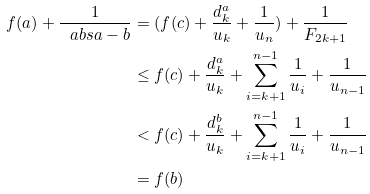<formula> <loc_0><loc_0><loc_500><loc_500>f ( a ) + \frac { 1 } { \ a b s { a - b } } & = ( f ( c ) + \frac { d ^ { a } _ { k } } { u _ { k } } + \frac { 1 } { u _ { n } } ) + \frac { 1 } { F _ { 2 k + 1 } } \\ & \leq f ( c ) + \frac { d ^ { a } _ { k } } { u _ { k } } + \sum _ { i = k + 1 } ^ { n - 1 } \frac { 1 } { u _ { i } } + \frac { 1 } { u _ { n - 1 } } \\ & < f ( c ) + \frac { d ^ { b } _ { k } } { u _ { k } } + \sum _ { i = k + 1 } ^ { n - 1 } \frac { 1 } { u _ { i } } + \frac { 1 } { u _ { n - 1 } } \\ & = f ( b )</formula> 